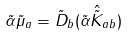Convert formula to latex. <formula><loc_0><loc_0><loc_500><loc_500>\tilde { \alpha } \tilde { \mu } _ { a } = \tilde { D } _ { b } ( \tilde { \alpha } \hat { \tilde { K } } _ { a b } )</formula> 